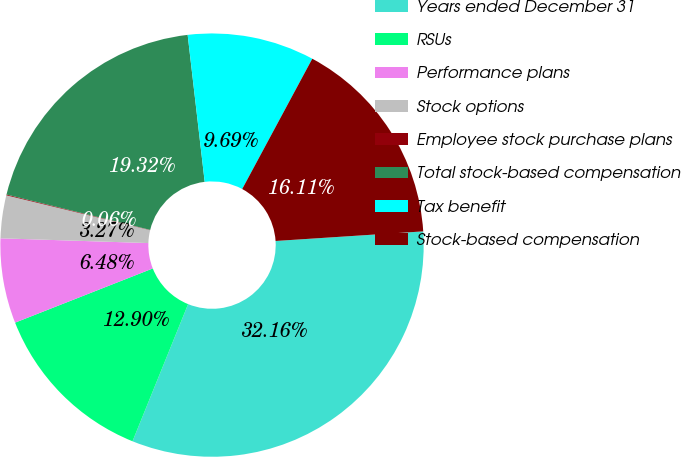Convert chart. <chart><loc_0><loc_0><loc_500><loc_500><pie_chart><fcel>Years ended December 31<fcel>RSUs<fcel>Performance plans<fcel>Stock options<fcel>Employee stock purchase plans<fcel>Total stock-based compensation<fcel>Tax benefit<fcel>Stock-based compensation<nl><fcel>32.16%<fcel>12.9%<fcel>6.48%<fcel>3.27%<fcel>0.06%<fcel>19.32%<fcel>9.69%<fcel>16.11%<nl></chart> 